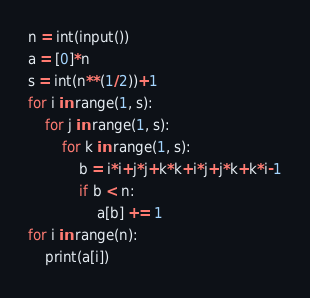Convert code to text. <code><loc_0><loc_0><loc_500><loc_500><_Python_>n = int(input())
a = [0]*n
s = int(n**(1/2))+1
for i in range(1, s):
    for j in range(1, s):
        for k in range(1, s):
            b = i*i+j*j+k*k+i*j+j*k+k*i-1
            if b < n:
                a[b] += 1
for i in range(n):
    print(a[i])</code> 